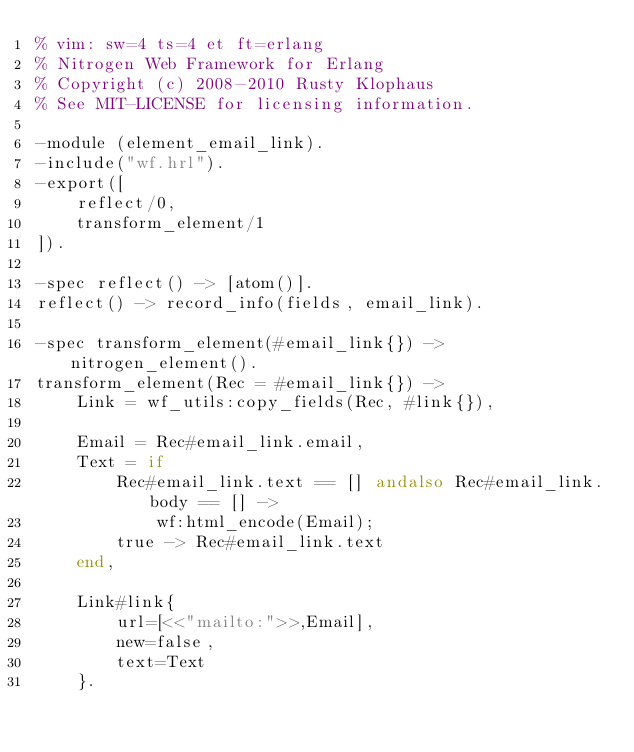<code> <loc_0><loc_0><loc_500><loc_500><_Erlang_>% vim: sw=4 ts=4 et ft=erlang
% Nitrogen Web Framework for Erlang
% Copyright (c) 2008-2010 Rusty Klophaus
% See MIT-LICENSE for licensing information.

-module (element_email_link).
-include("wf.hrl").
-export([
    reflect/0,
    transform_element/1
]).

-spec reflect() -> [atom()].
reflect() -> record_info(fields, email_link).

-spec transform_element(#email_link{}) -> nitrogen_element().
transform_element(Rec = #email_link{}) -> 
    Link = wf_utils:copy_fields(Rec, #link{}),

    Email = Rec#email_link.email,
    Text = if
        Rec#email_link.text == [] andalso Rec#email_link.body == [] ->
            wf:html_encode(Email);
        true -> Rec#email_link.text
    end,

    Link#link{
        url=[<<"mailto:">>,Email],
        new=false,
        text=Text
    }.
</code> 